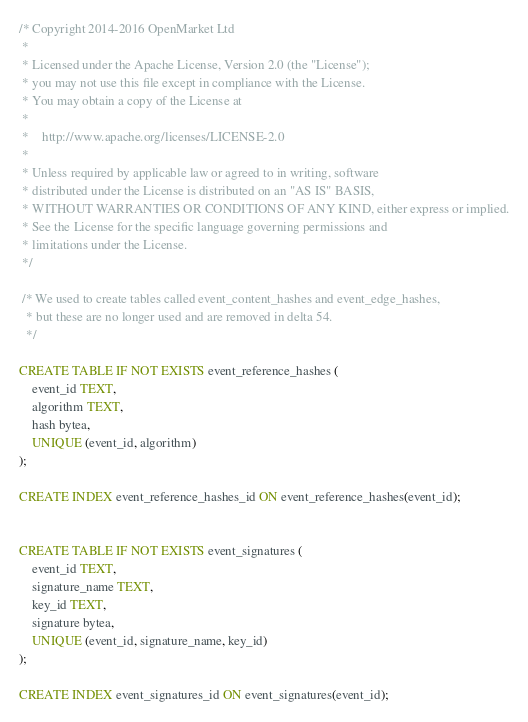Convert code to text. <code><loc_0><loc_0><loc_500><loc_500><_SQL_>/* Copyright 2014-2016 OpenMarket Ltd
 *
 * Licensed under the Apache License, Version 2.0 (the "License");
 * you may not use this file except in compliance with the License.
 * You may obtain a copy of the License at
 *
 *    http://www.apache.org/licenses/LICENSE-2.0
 *
 * Unless required by applicable law or agreed to in writing, software
 * distributed under the License is distributed on an "AS IS" BASIS,
 * WITHOUT WARRANTIES OR CONDITIONS OF ANY KIND, either express or implied.
 * See the License for the specific language governing permissions and
 * limitations under the License.
 */

 /* We used to create tables called event_content_hashes and event_edge_hashes,
  * but these are no longer used and are removed in delta 54.
  */

CREATE TABLE IF NOT EXISTS event_reference_hashes (
    event_id TEXT,
    algorithm TEXT,
    hash bytea,
    UNIQUE (event_id, algorithm)
);

CREATE INDEX event_reference_hashes_id ON event_reference_hashes(event_id);


CREATE TABLE IF NOT EXISTS event_signatures (
    event_id TEXT,
    signature_name TEXT,
    key_id TEXT,
    signature bytea,
    UNIQUE (event_id, signature_name, key_id)
);

CREATE INDEX event_signatures_id ON event_signatures(event_id);
</code> 